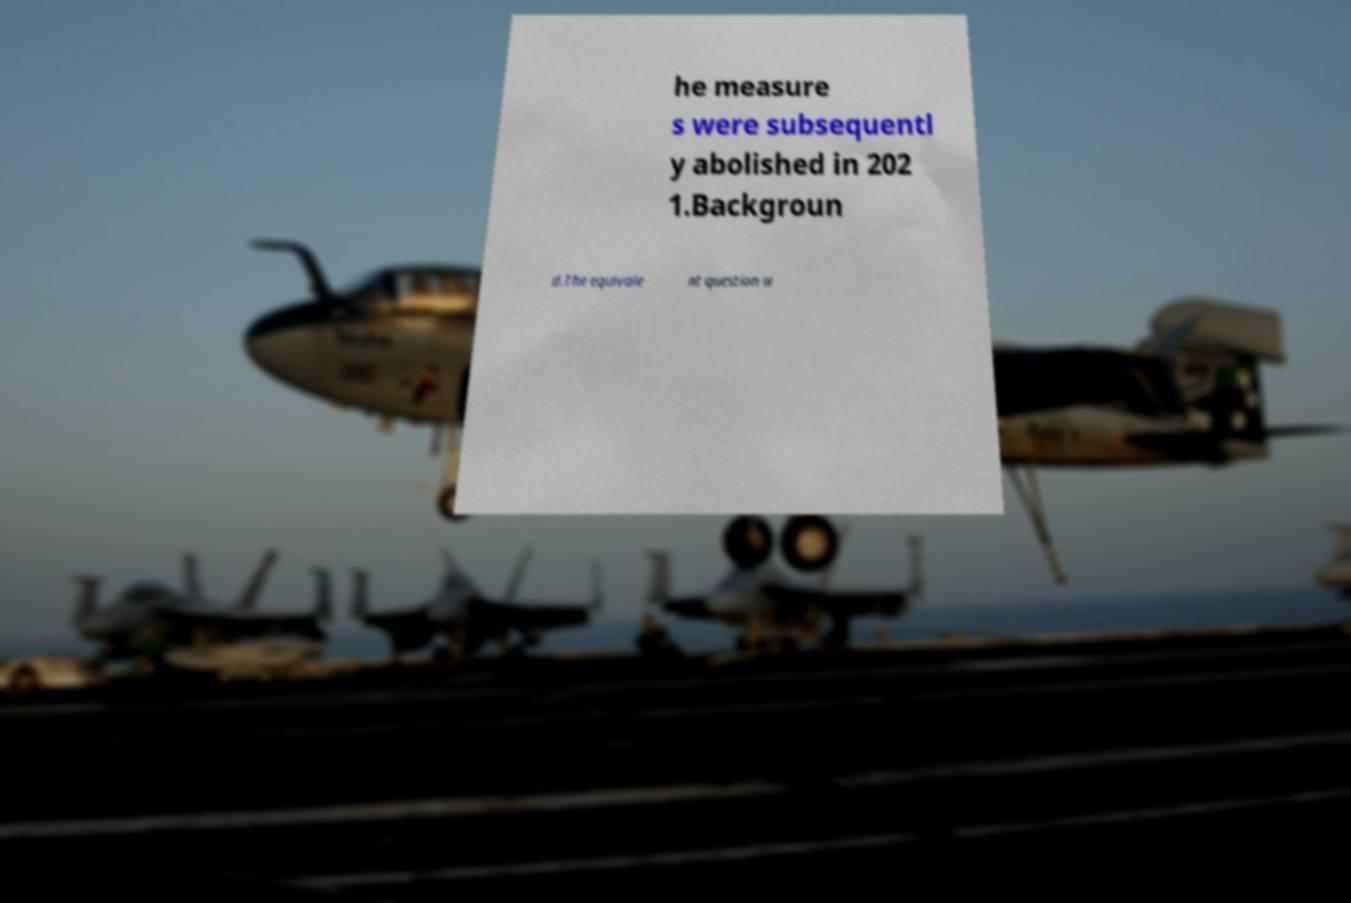Can you read and provide the text displayed in the image?This photo seems to have some interesting text. Can you extract and type it out for me? he measure s were subsequentl y abolished in 202 1.Backgroun d.The equivale nt question w 